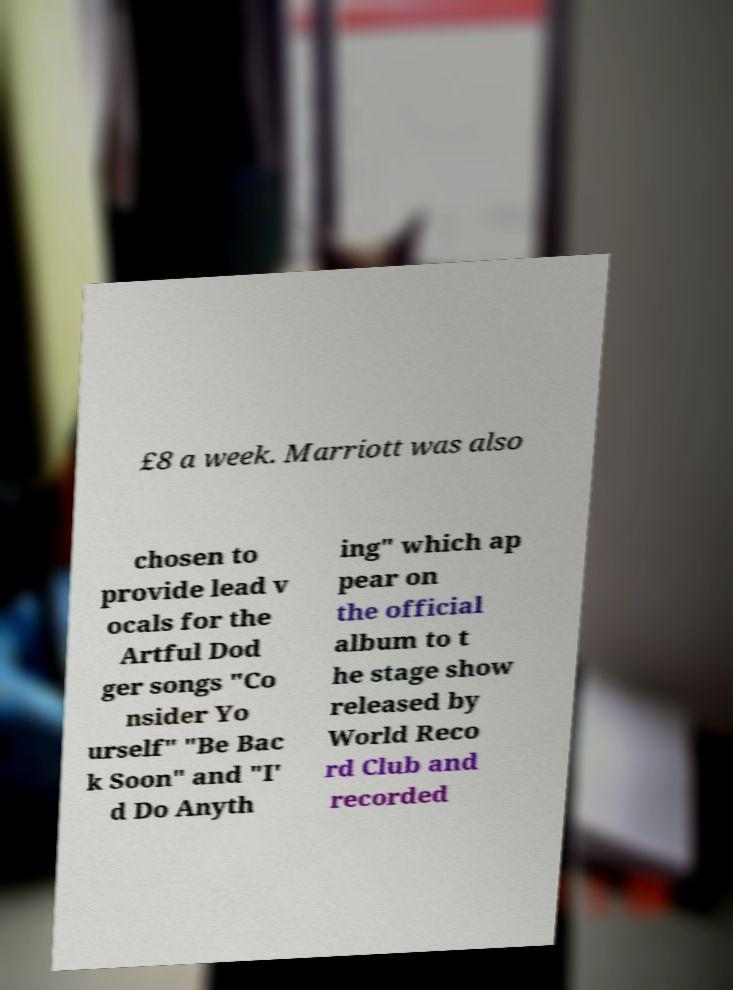For documentation purposes, I need the text within this image transcribed. Could you provide that? £8 a week. Marriott was also chosen to provide lead v ocals for the Artful Dod ger songs "Co nsider Yo urself" "Be Bac k Soon" and "I' d Do Anyth ing" which ap pear on the official album to t he stage show released by World Reco rd Club and recorded 